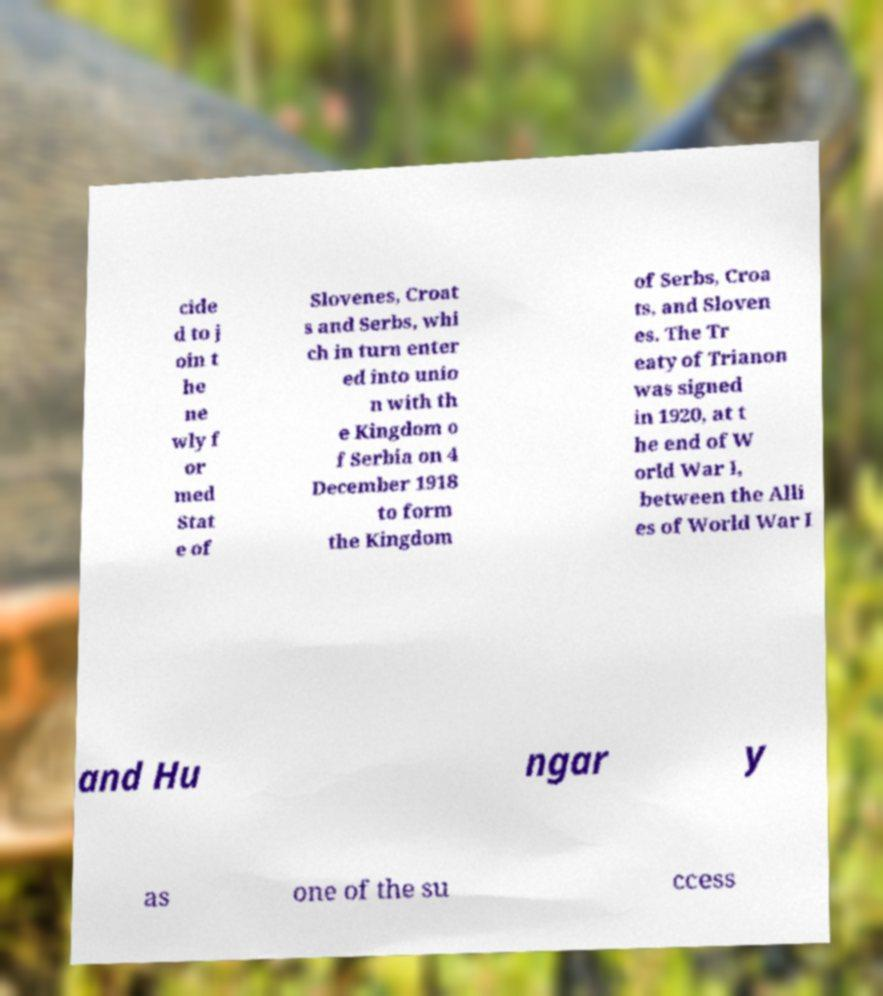What messages or text are displayed in this image? I need them in a readable, typed format. cide d to j oin t he ne wly f or med Stat e of Slovenes, Croat s and Serbs, whi ch in turn enter ed into unio n with th e Kingdom o f Serbia on 4 December 1918 to form the Kingdom of Serbs, Croa ts, and Sloven es. The Tr eaty of Trianon was signed in 1920, at t he end of W orld War I, between the Alli es of World War I and Hu ngar y as one of the su ccess 